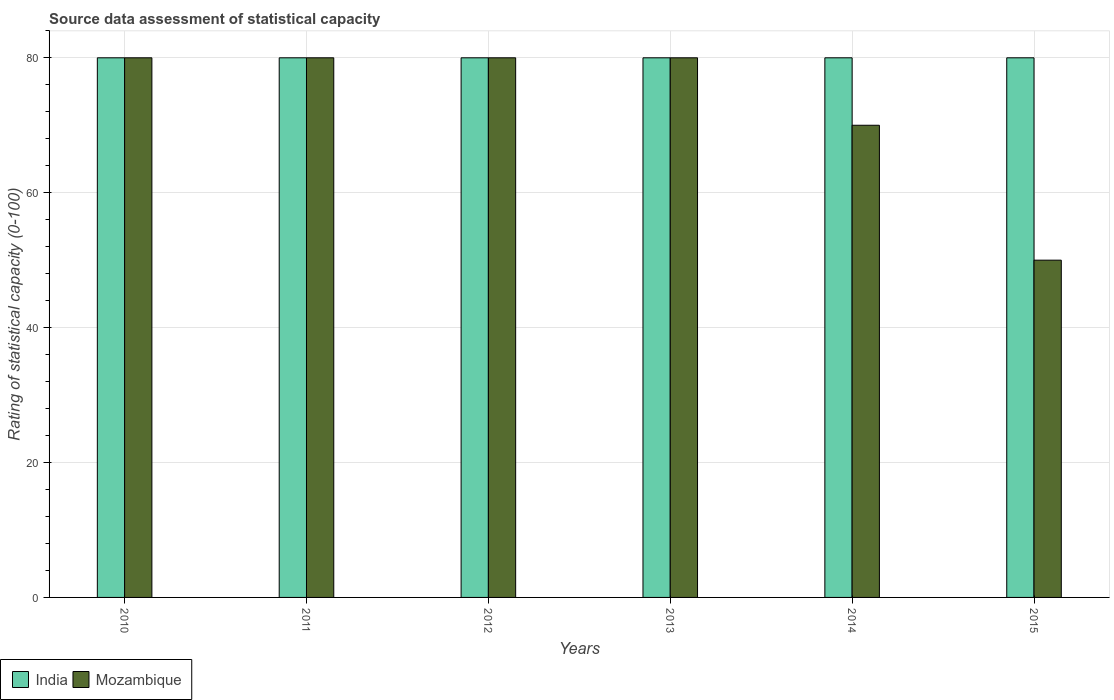Are the number of bars per tick equal to the number of legend labels?
Your answer should be compact. Yes. Are the number of bars on each tick of the X-axis equal?
Offer a terse response. Yes. How many bars are there on the 5th tick from the right?
Keep it short and to the point. 2. What is the label of the 1st group of bars from the left?
Your response must be concise. 2010. In how many cases, is the number of bars for a given year not equal to the number of legend labels?
Your answer should be very brief. 0. What is the rating of statistical capacity in India in 2010?
Keep it short and to the point. 80. Across all years, what is the maximum rating of statistical capacity in Mozambique?
Your answer should be compact. 80. Across all years, what is the minimum rating of statistical capacity in India?
Your answer should be very brief. 80. In which year was the rating of statistical capacity in India minimum?
Your answer should be compact. 2010. What is the total rating of statistical capacity in India in the graph?
Offer a very short reply. 480. What is the difference between the rating of statistical capacity in Mozambique in 2010 and that in 2013?
Provide a short and direct response. 0. What is the difference between the rating of statistical capacity in India in 2015 and the rating of statistical capacity in Mozambique in 2013?
Keep it short and to the point. 0. What is the average rating of statistical capacity in Mozambique per year?
Provide a succinct answer. 73.33. In the year 2014, what is the difference between the rating of statistical capacity in India and rating of statistical capacity in Mozambique?
Provide a short and direct response. 10. In how many years, is the rating of statistical capacity in Mozambique greater than 76?
Make the answer very short. 4. What is the difference between the highest and the second highest rating of statistical capacity in Mozambique?
Your answer should be compact. 0. What is the difference between the highest and the lowest rating of statistical capacity in Mozambique?
Your answer should be compact. 30. Is the sum of the rating of statistical capacity in India in 2012 and 2013 greater than the maximum rating of statistical capacity in Mozambique across all years?
Give a very brief answer. Yes. What does the 2nd bar from the left in 2012 represents?
Give a very brief answer. Mozambique. How many bars are there?
Ensure brevity in your answer.  12. Are all the bars in the graph horizontal?
Your response must be concise. No. What is the difference between two consecutive major ticks on the Y-axis?
Keep it short and to the point. 20. Does the graph contain grids?
Keep it short and to the point. Yes. How are the legend labels stacked?
Offer a very short reply. Horizontal. What is the title of the graph?
Your response must be concise. Source data assessment of statistical capacity. Does "United States" appear as one of the legend labels in the graph?
Your answer should be compact. No. What is the label or title of the X-axis?
Make the answer very short. Years. What is the label or title of the Y-axis?
Ensure brevity in your answer.  Rating of statistical capacity (0-100). What is the Rating of statistical capacity (0-100) of Mozambique in 2010?
Ensure brevity in your answer.  80. What is the Rating of statistical capacity (0-100) of India in 2011?
Keep it short and to the point. 80. What is the Rating of statistical capacity (0-100) of India in 2013?
Your answer should be compact. 80. What is the Rating of statistical capacity (0-100) of Mozambique in 2013?
Give a very brief answer. 80. What is the Rating of statistical capacity (0-100) in India in 2014?
Offer a terse response. 80. What is the Rating of statistical capacity (0-100) in Mozambique in 2014?
Your answer should be very brief. 70. What is the Rating of statistical capacity (0-100) in Mozambique in 2015?
Ensure brevity in your answer.  50. Across all years, what is the minimum Rating of statistical capacity (0-100) in Mozambique?
Offer a very short reply. 50. What is the total Rating of statistical capacity (0-100) in India in the graph?
Offer a very short reply. 480. What is the total Rating of statistical capacity (0-100) of Mozambique in the graph?
Make the answer very short. 440. What is the difference between the Rating of statistical capacity (0-100) in Mozambique in 2010 and that in 2011?
Your response must be concise. 0. What is the difference between the Rating of statistical capacity (0-100) of India in 2010 and that in 2012?
Your answer should be compact. 0. What is the difference between the Rating of statistical capacity (0-100) of Mozambique in 2010 and that in 2013?
Your answer should be very brief. 0. What is the difference between the Rating of statistical capacity (0-100) of India in 2010 and that in 2014?
Make the answer very short. 0. What is the difference between the Rating of statistical capacity (0-100) of India in 2010 and that in 2015?
Make the answer very short. 0. What is the difference between the Rating of statistical capacity (0-100) in Mozambique in 2011 and that in 2012?
Your answer should be compact. 0. What is the difference between the Rating of statistical capacity (0-100) of Mozambique in 2011 and that in 2013?
Your response must be concise. 0. What is the difference between the Rating of statistical capacity (0-100) of Mozambique in 2011 and that in 2014?
Give a very brief answer. 10. What is the difference between the Rating of statistical capacity (0-100) of India in 2011 and that in 2015?
Keep it short and to the point. 0. What is the difference between the Rating of statistical capacity (0-100) of Mozambique in 2012 and that in 2015?
Ensure brevity in your answer.  30. What is the difference between the Rating of statistical capacity (0-100) of India in 2013 and that in 2015?
Give a very brief answer. 0. What is the difference between the Rating of statistical capacity (0-100) in Mozambique in 2013 and that in 2015?
Ensure brevity in your answer.  30. What is the difference between the Rating of statistical capacity (0-100) of India in 2010 and the Rating of statistical capacity (0-100) of Mozambique in 2011?
Your answer should be compact. 0. What is the difference between the Rating of statistical capacity (0-100) in India in 2010 and the Rating of statistical capacity (0-100) in Mozambique in 2012?
Make the answer very short. 0. What is the difference between the Rating of statistical capacity (0-100) in India in 2010 and the Rating of statistical capacity (0-100) in Mozambique in 2013?
Your answer should be very brief. 0. What is the difference between the Rating of statistical capacity (0-100) in India in 2010 and the Rating of statistical capacity (0-100) in Mozambique in 2014?
Your answer should be very brief. 10. What is the difference between the Rating of statistical capacity (0-100) in India in 2010 and the Rating of statistical capacity (0-100) in Mozambique in 2015?
Offer a terse response. 30. What is the difference between the Rating of statistical capacity (0-100) of India in 2011 and the Rating of statistical capacity (0-100) of Mozambique in 2012?
Offer a very short reply. 0. What is the difference between the Rating of statistical capacity (0-100) of India in 2011 and the Rating of statistical capacity (0-100) of Mozambique in 2015?
Give a very brief answer. 30. What is the difference between the Rating of statistical capacity (0-100) of India in 2012 and the Rating of statistical capacity (0-100) of Mozambique in 2015?
Your answer should be very brief. 30. What is the difference between the Rating of statistical capacity (0-100) in India in 2014 and the Rating of statistical capacity (0-100) in Mozambique in 2015?
Provide a short and direct response. 30. What is the average Rating of statistical capacity (0-100) of India per year?
Provide a succinct answer. 80. What is the average Rating of statistical capacity (0-100) in Mozambique per year?
Offer a very short reply. 73.33. In the year 2011, what is the difference between the Rating of statistical capacity (0-100) of India and Rating of statistical capacity (0-100) of Mozambique?
Offer a terse response. 0. In the year 2014, what is the difference between the Rating of statistical capacity (0-100) in India and Rating of statistical capacity (0-100) in Mozambique?
Give a very brief answer. 10. In the year 2015, what is the difference between the Rating of statistical capacity (0-100) of India and Rating of statistical capacity (0-100) of Mozambique?
Offer a terse response. 30. What is the ratio of the Rating of statistical capacity (0-100) of India in 2010 to that in 2012?
Provide a succinct answer. 1. What is the ratio of the Rating of statistical capacity (0-100) in Mozambique in 2010 to that in 2013?
Your response must be concise. 1. What is the ratio of the Rating of statistical capacity (0-100) of India in 2010 to that in 2014?
Provide a succinct answer. 1. What is the ratio of the Rating of statistical capacity (0-100) in India in 2010 to that in 2015?
Your answer should be very brief. 1. What is the ratio of the Rating of statistical capacity (0-100) in India in 2011 to that in 2012?
Provide a succinct answer. 1. What is the ratio of the Rating of statistical capacity (0-100) in Mozambique in 2011 to that in 2012?
Provide a short and direct response. 1. What is the ratio of the Rating of statistical capacity (0-100) in India in 2012 to that in 2013?
Provide a short and direct response. 1. What is the ratio of the Rating of statistical capacity (0-100) in Mozambique in 2012 to that in 2013?
Your answer should be compact. 1. What is the ratio of the Rating of statistical capacity (0-100) of India in 2012 to that in 2014?
Make the answer very short. 1. What is the ratio of the Rating of statistical capacity (0-100) of Mozambique in 2012 to that in 2014?
Ensure brevity in your answer.  1.14. What is the ratio of the Rating of statistical capacity (0-100) of Mozambique in 2012 to that in 2015?
Make the answer very short. 1.6. What is the ratio of the Rating of statistical capacity (0-100) in India in 2013 to that in 2014?
Give a very brief answer. 1. What is the ratio of the Rating of statistical capacity (0-100) in Mozambique in 2013 to that in 2015?
Offer a terse response. 1.6. What is the difference between the highest and the second highest Rating of statistical capacity (0-100) of India?
Give a very brief answer. 0. What is the difference between the highest and the second highest Rating of statistical capacity (0-100) of Mozambique?
Provide a succinct answer. 0. What is the difference between the highest and the lowest Rating of statistical capacity (0-100) in Mozambique?
Provide a short and direct response. 30. 